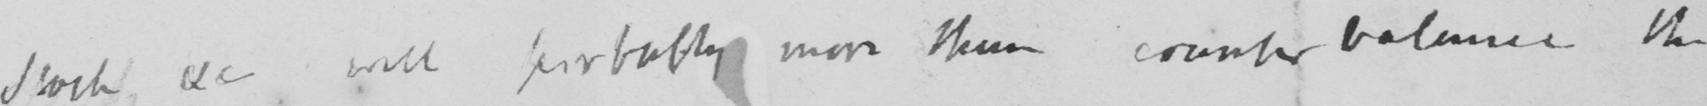Please provide the text content of this handwritten line. Stock use will probably more than counter balance the 